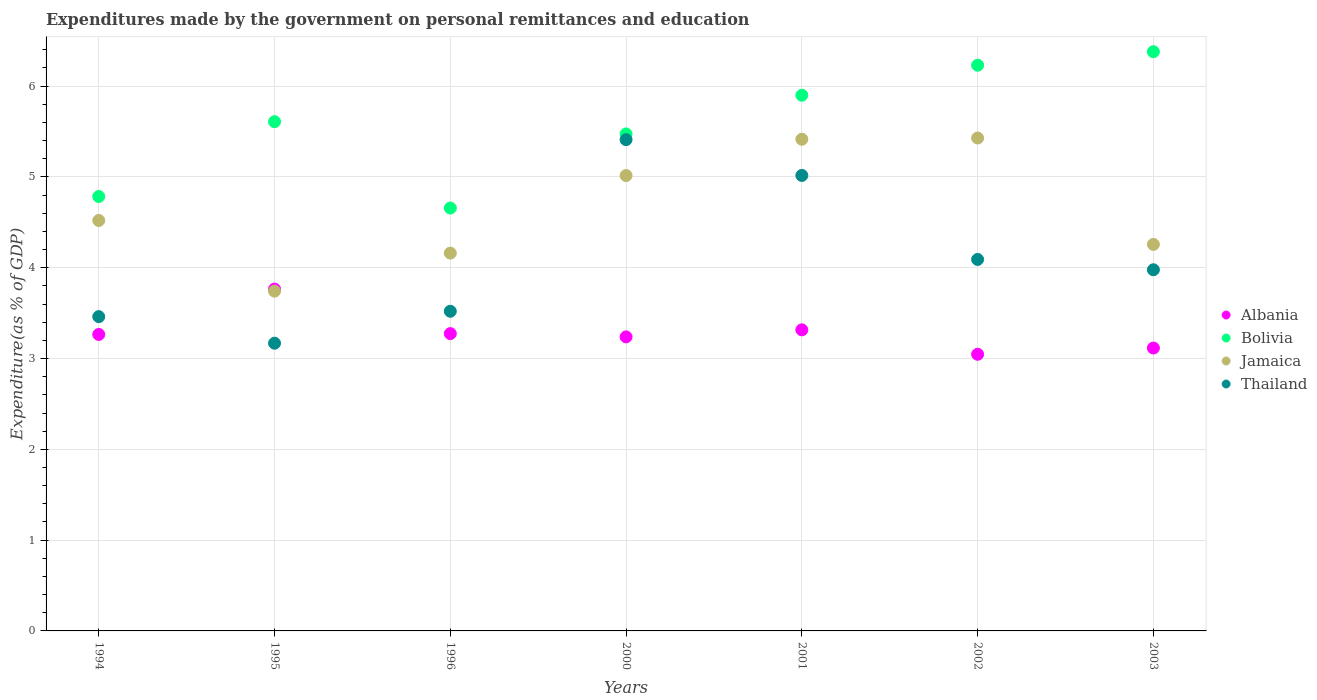What is the expenditures made by the government on personal remittances and education in Thailand in 2000?
Your response must be concise. 5.41. Across all years, what is the maximum expenditures made by the government on personal remittances and education in Bolivia?
Give a very brief answer. 6.38. Across all years, what is the minimum expenditures made by the government on personal remittances and education in Albania?
Your response must be concise. 3.05. In which year was the expenditures made by the government on personal remittances and education in Thailand maximum?
Provide a succinct answer. 2000. In which year was the expenditures made by the government on personal remittances and education in Bolivia minimum?
Your answer should be very brief. 1996. What is the total expenditures made by the government on personal remittances and education in Albania in the graph?
Keep it short and to the point. 23.02. What is the difference between the expenditures made by the government on personal remittances and education in Jamaica in 1996 and that in 2000?
Provide a succinct answer. -0.85. What is the difference between the expenditures made by the government on personal remittances and education in Bolivia in 2002 and the expenditures made by the government on personal remittances and education in Thailand in 2000?
Keep it short and to the point. 0.82. What is the average expenditures made by the government on personal remittances and education in Albania per year?
Make the answer very short. 3.29. In the year 2003, what is the difference between the expenditures made by the government on personal remittances and education in Jamaica and expenditures made by the government on personal remittances and education in Bolivia?
Provide a succinct answer. -2.12. What is the ratio of the expenditures made by the government on personal remittances and education in Bolivia in 1996 to that in 2003?
Your answer should be compact. 0.73. Is the expenditures made by the government on personal remittances and education in Jamaica in 1994 less than that in 2003?
Keep it short and to the point. No. What is the difference between the highest and the second highest expenditures made by the government on personal remittances and education in Thailand?
Keep it short and to the point. 0.39. What is the difference between the highest and the lowest expenditures made by the government on personal remittances and education in Bolivia?
Your answer should be very brief. 1.72. Does the expenditures made by the government on personal remittances and education in Bolivia monotonically increase over the years?
Keep it short and to the point. No. Is the expenditures made by the government on personal remittances and education in Thailand strictly less than the expenditures made by the government on personal remittances and education in Albania over the years?
Ensure brevity in your answer.  No. What is the difference between two consecutive major ticks on the Y-axis?
Your answer should be very brief. 1. Are the values on the major ticks of Y-axis written in scientific E-notation?
Provide a succinct answer. No. Does the graph contain any zero values?
Your answer should be very brief. No. Does the graph contain grids?
Your answer should be very brief. Yes. Where does the legend appear in the graph?
Offer a very short reply. Center right. How many legend labels are there?
Offer a terse response. 4. How are the legend labels stacked?
Ensure brevity in your answer.  Vertical. What is the title of the graph?
Provide a short and direct response. Expenditures made by the government on personal remittances and education. What is the label or title of the X-axis?
Provide a short and direct response. Years. What is the label or title of the Y-axis?
Your answer should be compact. Expenditure(as % of GDP). What is the Expenditure(as % of GDP) in Albania in 1994?
Your answer should be very brief. 3.27. What is the Expenditure(as % of GDP) of Bolivia in 1994?
Provide a short and direct response. 4.78. What is the Expenditure(as % of GDP) of Jamaica in 1994?
Your response must be concise. 4.52. What is the Expenditure(as % of GDP) in Thailand in 1994?
Your answer should be compact. 3.46. What is the Expenditure(as % of GDP) in Albania in 1995?
Ensure brevity in your answer.  3.76. What is the Expenditure(as % of GDP) in Bolivia in 1995?
Offer a very short reply. 5.61. What is the Expenditure(as % of GDP) of Jamaica in 1995?
Give a very brief answer. 3.74. What is the Expenditure(as % of GDP) of Thailand in 1995?
Your answer should be compact. 3.17. What is the Expenditure(as % of GDP) of Albania in 1996?
Keep it short and to the point. 3.27. What is the Expenditure(as % of GDP) in Bolivia in 1996?
Your answer should be very brief. 4.66. What is the Expenditure(as % of GDP) in Jamaica in 1996?
Provide a succinct answer. 4.16. What is the Expenditure(as % of GDP) of Thailand in 1996?
Ensure brevity in your answer.  3.52. What is the Expenditure(as % of GDP) in Albania in 2000?
Keep it short and to the point. 3.24. What is the Expenditure(as % of GDP) of Bolivia in 2000?
Keep it short and to the point. 5.47. What is the Expenditure(as % of GDP) of Jamaica in 2000?
Offer a terse response. 5.02. What is the Expenditure(as % of GDP) in Thailand in 2000?
Provide a succinct answer. 5.41. What is the Expenditure(as % of GDP) in Albania in 2001?
Keep it short and to the point. 3.32. What is the Expenditure(as % of GDP) in Bolivia in 2001?
Make the answer very short. 5.9. What is the Expenditure(as % of GDP) in Jamaica in 2001?
Offer a very short reply. 5.41. What is the Expenditure(as % of GDP) of Thailand in 2001?
Keep it short and to the point. 5.02. What is the Expenditure(as % of GDP) of Albania in 2002?
Offer a terse response. 3.05. What is the Expenditure(as % of GDP) of Bolivia in 2002?
Offer a very short reply. 6.23. What is the Expenditure(as % of GDP) in Jamaica in 2002?
Offer a terse response. 5.43. What is the Expenditure(as % of GDP) of Thailand in 2002?
Make the answer very short. 4.09. What is the Expenditure(as % of GDP) of Albania in 2003?
Your response must be concise. 3.12. What is the Expenditure(as % of GDP) in Bolivia in 2003?
Provide a short and direct response. 6.38. What is the Expenditure(as % of GDP) of Jamaica in 2003?
Ensure brevity in your answer.  4.26. What is the Expenditure(as % of GDP) in Thailand in 2003?
Ensure brevity in your answer.  3.98. Across all years, what is the maximum Expenditure(as % of GDP) of Albania?
Provide a succinct answer. 3.76. Across all years, what is the maximum Expenditure(as % of GDP) of Bolivia?
Give a very brief answer. 6.38. Across all years, what is the maximum Expenditure(as % of GDP) of Jamaica?
Offer a very short reply. 5.43. Across all years, what is the maximum Expenditure(as % of GDP) of Thailand?
Provide a short and direct response. 5.41. Across all years, what is the minimum Expenditure(as % of GDP) in Albania?
Your answer should be compact. 3.05. Across all years, what is the minimum Expenditure(as % of GDP) in Bolivia?
Your response must be concise. 4.66. Across all years, what is the minimum Expenditure(as % of GDP) of Jamaica?
Ensure brevity in your answer.  3.74. Across all years, what is the minimum Expenditure(as % of GDP) of Thailand?
Offer a terse response. 3.17. What is the total Expenditure(as % of GDP) in Albania in the graph?
Offer a terse response. 23.02. What is the total Expenditure(as % of GDP) of Bolivia in the graph?
Provide a succinct answer. 39.03. What is the total Expenditure(as % of GDP) in Jamaica in the graph?
Give a very brief answer. 32.54. What is the total Expenditure(as % of GDP) in Thailand in the graph?
Ensure brevity in your answer.  28.65. What is the difference between the Expenditure(as % of GDP) in Albania in 1994 and that in 1995?
Provide a short and direct response. -0.5. What is the difference between the Expenditure(as % of GDP) in Bolivia in 1994 and that in 1995?
Offer a very short reply. -0.82. What is the difference between the Expenditure(as % of GDP) of Jamaica in 1994 and that in 1995?
Keep it short and to the point. 0.78. What is the difference between the Expenditure(as % of GDP) in Thailand in 1994 and that in 1995?
Give a very brief answer. 0.29. What is the difference between the Expenditure(as % of GDP) in Albania in 1994 and that in 1996?
Give a very brief answer. -0.01. What is the difference between the Expenditure(as % of GDP) in Bolivia in 1994 and that in 1996?
Provide a short and direct response. 0.13. What is the difference between the Expenditure(as % of GDP) in Jamaica in 1994 and that in 1996?
Provide a short and direct response. 0.36. What is the difference between the Expenditure(as % of GDP) in Thailand in 1994 and that in 1996?
Offer a very short reply. -0.06. What is the difference between the Expenditure(as % of GDP) of Albania in 1994 and that in 2000?
Keep it short and to the point. 0.03. What is the difference between the Expenditure(as % of GDP) in Bolivia in 1994 and that in 2000?
Offer a terse response. -0.69. What is the difference between the Expenditure(as % of GDP) of Jamaica in 1994 and that in 2000?
Your answer should be compact. -0.49. What is the difference between the Expenditure(as % of GDP) in Thailand in 1994 and that in 2000?
Your answer should be compact. -1.95. What is the difference between the Expenditure(as % of GDP) of Albania in 1994 and that in 2001?
Your answer should be very brief. -0.05. What is the difference between the Expenditure(as % of GDP) of Bolivia in 1994 and that in 2001?
Give a very brief answer. -1.12. What is the difference between the Expenditure(as % of GDP) of Jamaica in 1994 and that in 2001?
Provide a succinct answer. -0.89. What is the difference between the Expenditure(as % of GDP) in Thailand in 1994 and that in 2001?
Your answer should be very brief. -1.56. What is the difference between the Expenditure(as % of GDP) of Albania in 1994 and that in 2002?
Ensure brevity in your answer.  0.22. What is the difference between the Expenditure(as % of GDP) in Bolivia in 1994 and that in 2002?
Give a very brief answer. -1.45. What is the difference between the Expenditure(as % of GDP) of Jamaica in 1994 and that in 2002?
Make the answer very short. -0.91. What is the difference between the Expenditure(as % of GDP) of Thailand in 1994 and that in 2002?
Ensure brevity in your answer.  -0.63. What is the difference between the Expenditure(as % of GDP) in Albania in 1994 and that in 2003?
Your answer should be compact. 0.15. What is the difference between the Expenditure(as % of GDP) in Bolivia in 1994 and that in 2003?
Make the answer very short. -1.59. What is the difference between the Expenditure(as % of GDP) in Jamaica in 1994 and that in 2003?
Your answer should be compact. 0.26. What is the difference between the Expenditure(as % of GDP) of Thailand in 1994 and that in 2003?
Keep it short and to the point. -0.52. What is the difference between the Expenditure(as % of GDP) of Albania in 1995 and that in 1996?
Make the answer very short. 0.49. What is the difference between the Expenditure(as % of GDP) in Bolivia in 1995 and that in 1996?
Make the answer very short. 0.95. What is the difference between the Expenditure(as % of GDP) in Jamaica in 1995 and that in 1996?
Your answer should be very brief. -0.42. What is the difference between the Expenditure(as % of GDP) of Thailand in 1995 and that in 1996?
Offer a very short reply. -0.35. What is the difference between the Expenditure(as % of GDP) of Albania in 1995 and that in 2000?
Keep it short and to the point. 0.53. What is the difference between the Expenditure(as % of GDP) in Bolivia in 1995 and that in 2000?
Make the answer very short. 0.13. What is the difference between the Expenditure(as % of GDP) in Jamaica in 1995 and that in 2000?
Keep it short and to the point. -1.27. What is the difference between the Expenditure(as % of GDP) of Thailand in 1995 and that in 2000?
Keep it short and to the point. -2.24. What is the difference between the Expenditure(as % of GDP) of Albania in 1995 and that in 2001?
Make the answer very short. 0.45. What is the difference between the Expenditure(as % of GDP) in Bolivia in 1995 and that in 2001?
Ensure brevity in your answer.  -0.29. What is the difference between the Expenditure(as % of GDP) of Jamaica in 1995 and that in 2001?
Provide a short and direct response. -1.67. What is the difference between the Expenditure(as % of GDP) in Thailand in 1995 and that in 2001?
Provide a short and direct response. -1.85. What is the difference between the Expenditure(as % of GDP) in Albania in 1995 and that in 2002?
Keep it short and to the point. 0.72. What is the difference between the Expenditure(as % of GDP) in Bolivia in 1995 and that in 2002?
Keep it short and to the point. -0.62. What is the difference between the Expenditure(as % of GDP) in Jamaica in 1995 and that in 2002?
Your answer should be compact. -1.69. What is the difference between the Expenditure(as % of GDP) in Thailand in 1995 and that in 2002?
Keep it short and to the point. -0.92. What is the difference between the Expenditure(as % of GDP) of Albania in 1995 and that in 2003?
Your response must be concise. 0.65. What is the difference between the Expenditure(as % of GDP) in Bolivia in 1995 and that in 2003?
Give a very brief answer. -0.77. What is the difference between the Expenditure(as % of GDP) of Jamaica in 1995 and that in 2003?
Keep it short and to the point. -0.51. What is the difference between the Expenditure(as % of GDP) in Thailand in 1995 and that in 2003?
Your answer should be very brief. -0.81. What is the difference between the Expenditure(as % of GDP) of Albania in 1996 and that in 2000?
Make the answer very short. 0.04. What is the difference between the Expenditure(as % of GDP) of Bolivia in 1996 and that in 2000?
Make the answer very short. -0.82. What is the difference between the Expenditure(as % of GDP) in Jamaica in 1996 and that in 2000?
Keep it short and to the point. -0.85. What is the difference between the Expenditure(as % of GDP) of Thailand in 1996 and that in 2000?
Give a very brief answer. -1.89. What is the difference between the Expenditure(as % of GDP) in Albania in 1996 and that in 2001?
Keep it short and to the point. -0.04. What is the difference between the Expenditure(as % of GDP) in Bolivia in 1996 and that in 2001?
Provide a short and direct response. -1.24. What is the difference between the Expenditure(as % of GDP) in Jamaica in 1996 and that in 2001?
Keep it short and to the point. -1.25. What is the difference between the Expenditure(as % of GDP) in Thailand in 1996 and that in 2001?
Keep it short and to the point. -1.5. What is the difference between the Expenditure(as % of GDP) of Albania in 1996 and that in 2002?
Ensure brevity in your answer.  0.23. What is the difference between the Expenditure(as % of GDP) in Bolivia in 1996 and that in 2002?
Provide a short and direct response. -1.57. What is the difference between the Expenditure(as % of GDP) in Jamaica in 1996 and that in 2002?
Provide a short and direct response. -1.27. What is the difference between the Expenditure(as % of GDP) in Thailand in 1996 and that in 2002?
Keep it short and to the point. -0.57. What is the difference between the Expenditure(as % of GDP) of Albania in 1996 and that in 2003?
Your answer should be very brief. 0.16. What is the difference between the Expenditure(as % of GDP) of Bolivia in 1996 and that in 2003?
Offer a terse response. -1.72. What is the difference between the Expenditure(as % of GDP) of Jamaica in 1996 and that in 2003?
Your response must be concise. -0.1. What is the difference between the Expenditure(as % of GDP) of Thailand in 1996 and that in 2003?
Provide a succinct answer. -0.46. What is the difference between the Expenditure(as % of GDP) in Albania in 2000 and that in 2001?
Ensure brevity in your answer.  -0.08. What is the difference between the Expenditure(as % of GDP) of Bolivia in 2000 and that in 2001?
Your answer should be very brief. -0.43. What is the difference between the Expenditure(as % of GDP) in Jamaica in 2000 and that in 2001?
Provide a succinct answer. -0.4. What is the difference between the Expenditure(as % of GDP) in Thailand in 2000 and that in 2001?
Provide a succinct answer. 0.39. What is the difference between the Expenditure(as % of GDP) in Albania in 2000 and that in 2002?
Give a very brief answer. 0.19. What is the difference between the Expenditure(as % of GDP) of Bolivia in 2000 and that in 2002?
Offer a very short reply. -0.76. What is the difference between the Expenditure(as % of GDP) in Jamaica in 2000 and that in 2002?
Offer a terse response. -0.41. What is the difference between the Expenditure(as % of GDP) in Thailand in 2000 and that in 2002?
Provide a succinct answer. 1.32. What is the difference between the Expenditure(as % of GDP) in Albania in 2000 and that in 2003?
Provide a succinct answer. 0.12. What is the difference between the Expenditure(as % of GDP) in Bolivia in 2000 and that in 2003?
Make the answer very short. -0.91. What is the difference between the Expenditure(as % of GDP) of Jamaica in 2000 and that in 2003?
Ensure brevity in your answer.  0.76. What is the difference between the Expenditure(as % of GDP) of Thailand in 2000 and that in 2003?
Offer a terse response. 1.43. What is the difference between the Expenditure(as % of GDP) of Albania in 2001 and that in 2002?
Provide a succinct answer. 0.27. What is the difference between the Expenditure(as % of GDP) in Bolivia in 2001 and that in 2002?
Your response must be concise. -0.33. What is the difference between the Expenditure(as % of GDP) of Jamaica in 2001 and that in 2002?
Your answer should be compact. -0.01. What is the difference between the Expenditure(as % of GDP) in Thailand in 2001 and that in 2002?
Your answer should be compact. 0.93. What is the difference between the Expenditure(as % of GDP) in Albania in 2001 and that in 2003?
Make the answer very short. 0.2. What is the difference between the Expenditure(as % of GDP) in Bolivia in 2001 and that in 2003?
Ensure brevity in your answer.  -0.48. What is the difference between the Expenditure(as % of GDP) of Jamaica in 2001 and that in 2003?
Offer a terse response. 1.16. What is the difference between the Expenditure(as % of GDP) of Thailand in 2001 and that in 2003?
Offer a very short reply. 1.04. What is the difference between the Expenditure(as % of GDP) in Albania in 2002 and that in 2003?
Offer a very short reply. -0.07. What is the difference between the Expenditure(as % of GDP) of Bolivia in 2002 and that in 2003?
Offer a terse response. -0.15. What is the difference between the Expenditure(as % of GDP) in Jamaica in 2002 and that in 2003?
Your answer should be compact. 1.17. What is the difference between the Expenditure(as % of GDP) in Thailand in 2002 and that in 2003?
Keep it short and to the point. 0.11. What is the difference between the Expenditure(as % of GDP) of Albania in 1994 and the Expenditure(as % of GDP) of Bolivia in 1995?
Your response must be concise. -2.34. What is the difference between the Expenditure(as % of GDP) of Albania in 1994 and the Expenditure(as % of GDP) of Jamaica in 1995?
Ensure brevity in your answer.  -0.48. What is the difference between the Expenditure(as % of GDP) in Albania in 1994 and the Expenditure(as % of GDP) in Thailand in 1995?
Give a very brief answer. 0.1. What is the difference between the Expenditure(as % of GDP) of Bolivia in 1994 and the Expenditure(as % of GDP) of Jamaica in 1995?
Your answer should be very brief. 1.04. What is the difference between the Expenditure(as % of GDP) in Bolivia in 1994 and the Expenditure(as % of GDP) in Thailand in 1995?
Provide a short and direct response. 1.62. What is the difference between the Expenditure(as % of GDP) of Jamaica in 1994 and the Expenditure(as % of GDP) of Thailand in 1995?
Give a very brief answer. 1.35. What is the difference between the Expenditure(as % of GDP) in Albania in 1994 and the Expenditure(as % of GDP) in Bolivia in 1996?
Make the answer very short. -1.39. What is the difference between the Expenditure(as % of GDP) of Albania in 1994 and the Expenditure(as % of GDP) of Jamaica in 1996?
Offer a terse response. -0.9. What is the difference between the Expenditure(as % of GDP) of Albania in 1994 and the Expenditure(as % of GDP) of Thailand in 1996?
Ensure brevity in your answer.  -0.26. What is the difference between the Expenditure(as % of GDP) of Bolivia in 1994 and the Expenditure(as % of GDP) of Jamaica in 1996?
Your answer should be compact. 0.62. What is the difference between the Expenditure(as % of GDP) in Bolivia in 1994 and the Expenditure(as % of GDP) in Thailand in 1996?
Offer a very short reply. 1.26. What is the difference between the Expenditure(as % of GDP) of Jamaica in 1994 and the Expenditure(as % of GDP) of Thailand in 1996?
Your answer should be very brief. 1. What is the difference between the Expenditure(as % of GDP) of Albania in 1994 and the Expenditure(as % of GDP) of Bolivia in 2000?
Provide a succinct answer. -2.21. What is the difference between the Expenditure(as % of GDP) in Albania in 1994 and the Expenditure(as % of GDP) in Jamaica in 2000?
Ensure brevity in your answer.  -1.75. What is the difference between the Expenditure(as % of GDP) of Albania in 1994 and the Expenditure(as % of GDP) of Thailand in 2000?
Ensure brevity in your answer.  -2.15. What is the difference between the Expenditure(as % of GDP) of Bolivia in 1994 and the Expenditure(as % of GDP) of Jamaica in 2000?
Make the answer very short. -0.23. What is the difference between the Expenditure(as % of GDP) of Bolivia in 1994 and the Expenditure(as % of GDP) of Thailand in 2000?
Provide a short and direct response. -0.63. What is the difference between the Expenditure(as % of GDP) in Jamaica in 1994 and the Expenditure(as % of GDP) in Thailand in 2000?
Provide a short and direct response. -0.89. What is the difference between the Expenditure(as % of GDP) in Albania in 1994 and the Expenditure(as % of GDP) in Bolivia in 2001?
Keep it short and to the point. -2.63. What is the difference between the Expenditure(as % of GDP) in Albania in 1994 and the Expenditure(as % of GDP) in Jamaica in 2001?
Keep it short and to the point. -2.15. What is the difference between the Expenditure(as % of GDP) of Albania in 1994 and the Expenditure(as % of GDP) of Thailand in 2001?
Keep it short and to the point. -1.75. What is the difference between the Expenditure(as % of GDP) of Bolivia in 1994 and the Expenditure(as % of GDP) of Jamaica in 2001?
Keep it short and to the point. -0.63. What is the difference between the Expenditure(as % of GDP) of Bolivia in 1994 and the Expenditure(as % of GDP) of Thailand in 2001?
Your response must be concise. -0.23. What is the difference between the Expenditure(as % of GDP) of Jamaica in 1994 and the Expenditure(as % of GDP) of Thailand in 2001?
Your response must be concise. -0.5. What is the difference between the Expenditure(as % of GDP) of Albania in 1994 and the Expenditure(as % of GDP) of Bolivia in 2002?
Give a very brief answer. -2.97. What is the difference between the Expenditure(as % of GDP) in Albania in 1994 and the Expenditure(as % of GDP) in Jamaica in 2002?
Ensure brevity in your answer.  -2.16. What is the difference between the Expenditure(as % of GDP) in Albania in 1994 and the Expenditure(as % of GDP) in Thailand in 2002?
Provide a succinct answer. -0.83. What is the difference between the Expenditure(as % of GDP) of Bolivia in 1994 and the Expenditure(as % of GDP) of Jamaica in 2002?
Your response must be concise. -0.64. What is the difference between the Expenditure(as % of GDP) in Bolivia in 1994 and the Expenditure(as % of GDP) in Thailand in 2002?
Your response must be concise. 0.69. What is the difference between the Expenditure(as % of GDP) of Jamaica in 1994 and the Expenditure(as % of GDP) of Thailand in 2002?
Your answer should be compact. 0.43. What is the difference between the Expenditure(as % of GDP) in Albania in 1994 and the Expenditure(as % of GDP) in Bolivia in 2003?
Ensure brevity in your answer.  -3.11. What is the difference between the Expenditure(as % of GDP) of Albania in 1994 and the Expenditure(as % of GDP) of Jamaica in 2003?
Give a very brief answer. -0.99. What is the difference between the Expenditure(as % of GDP) in Albania in 1994 and the Expenditure(as % of GDP) in Thailand in 2003?
Give a very brief answer. -0.71. What is the difference between the Expenditure(as % of GDP) in Bolivia in 1994 and the Expenditure(as % of GDP) in Jamaica in 2003?
Ensure brevity in your answer.  0.53. What is the difference between the Expenditure(as % of GDP) in Bolivia in 1994 and the Expenditure(as % of GDP) in Thailand in 2003?
Offer a terse response. 0.81. What is the difference between the Expenditure(as % of GDP) in Jamaica in 1994 and the Expenditure(as % of GDP) in Thailand in 2003?
Provide a succinct answer. 0.54. What is the difference between the Expenditure(as % of GDP) of Albania in 1995 and the Expenditure(as % of GDP) of Bolivia in 1996?
Offer a terse response. -0.89. What is the difference between the Expenditure(as % of GDP) in Albania in 1995 and the Expenditure(as % of GDP) in Jamaica in 1996?
Your answer should be compact. -0.4. What is the difference between the Expenditure(as % of GDP) of Albania in 1995 and the Expenditure(as % of GDP) of Thailand in 1996?
Provide a succinct answer. 0.24. What is the difference between the Expenditure(as % of GDP) in Bolivia in 1995 and the Expenditure(as % of GDP) in Jamaica in 1996?
Offer a terse response. 1.45. What is the difference between the Expenditure(as % of GDP) in Bolivia in 1995 and the Expenditure(as % of GDP) in Thailand in 1996?
Make the answer very short. 2.09. What is the difference between the Expenditure(as % of GDP) of Jamaica in 1995 and the Expenditure(as % of GDP) of Thailand in 1996?
Offer a terse response. 0.22. What is the difference between the Expenditure(as % of GDP) of Albania in 1995 and the Expenditure(as % of GDP) of Bolivia in 2000?
Ensure brevity in your answer.  -1.71. What is the difference between the Expenditure(as % of GDP) in Albania in 1995 and the Expenditure(as % of GDP) in Jamaica in 2000?
Provide a succinct answer. -1.25. What is the difference between the Expenditure(as % of GDP) of Albania in 1995 and the Expenditure(as % of GDP) of Thailand in 2000?
Provide a short and direct response. -1.65. What is the difference between the Expenditure(as % of GDP) in Bolivia in 1995 and the Expenditure(as % of GDP) in Jamaica in 2000?
Offer a very short reply. 0.59. What is the difference between the Expenditure(as % of GDP) in Bolivia in 1995 and the Expenditure(as % of GDP) in Thailand in 2000?
Offer a terse response. 0.2. What is the difference between the Expenditure(as % of GDP) of Jamaica in 1995 and the Expenditure(as % of GDP) of Thailand in 2000?
Provide a succinct answer. -1.67. What is the difference between the Expenditure(as % of GDP) in Albania in 1995 and the Expenditure(as % of GDP) in Bolivia in 2001?
Ensure brevity in your answer.  -2.13. What is the difference between the Expenditure(as % of GDP) of Albania in 1995 and the Expenditure(as % of GDP) of Jamaica in 2001?
Provide a short and direct response. -1.65. What is the difference between the Expenditure(as % of GDP) of Albania in 1995 and the Expenditure(as % of GDP) of Thailand in 2001?
Your answer should be very brief. -1.25. What is the difference between the Expenditure(as % of GDP) of Bolivia in 1995 and the Expenditure(as % of GDP) of Jamaica in 2001?
Make the answer very short. 0.19. What is the difference between the Expenditure(as % of GDP) in Bolivia in 1995 and the Expenditure(as % of GDP) in Thailand in 2001?
Keep it short and to the point. 0.59. What is the difference between the Expenditure(as % of GDP) of Jamaica in 1995 and the Expenditure(as % of GDP) of Thailand in 2001?
Provide a short and direct response. -1.27. What is the difference between the Expenditure(as % of GDP) in Albania in 1995 and the Expenditure(as % of GDP) in Bolivia in 2002?
Provide a succinct answer. -2.47. What is the difference between the Expenditure(as % of GDP) in Albania in 1995 and the Expenditure(as % of GDP) in Jamaica in 2002?
Keep it short and to the point. -1.66. What is the difference between the Expenditure(as % of GDP) in Albania in 1995 and the Expenditure(as % of GDP) in Thailand in 2002?
Offer a very short reply. -0.33. What is the difference between the Expenditure(as % of GDP) of Bolivia in 1995 and the Expenditure(as % of GDP) of Jamaica in 2002?
Offer a very short reply. 0.18. What is the difference between the Expenditure(as % of GDP) of Bolivia in 1995 and the Expenditure(as % of GDP) of Thailand in 2002?
Your response must be concise. 1.52. What is the difference between the Expenditure(as % of GDP) of Jamaica in 1995 and the Expenditure(as % of GDP) of Thailand in 2002?
Offer a very short reply. -0.35. What is the difference between the Expenditure(as % of GDP) in Albania in 1995 and the Expenditure(as % of GDP) in Bolivia in 2003?
Keep it short and to the point. -2.61. What is the difference between the Expenditure(as % of GDP) in Albania in 1995 and the Expenditure(as % of GDP) in Jamaica in 2003?
Offer a terse response. -0.49. What is the difference between the Expenditure(as % of GDP) in Albania in 1995 and the Expenditure(as % of GDP) in Thailand in 2003?
Make the answer very short. -0.21. What is the difference between the Expenditure(as % of GDP) in Bolivia in 1995 and the Expenditure(as % of GDP) in Jamaica in 2003?
Give a very brief answer. 1.35. What is the difference between the Expenditure(as % of GDP) of Bolivia in 1995 and the Expenditure(as % of GDP) of Thailand in 2003?
Your answer should be compact. 1.63. What is the difference between the Expenditure(as % of GDP) in Jamaica in 1995 and the Expenditure(as % of GDP) in Thailand in 2003?
Provide a succinct answer. -0.24. What is the difference between the Expenditure(as % of GDP) in Albania in 1996 and the Expenditure(as % of GDP) in Bolivia in 2000?
Your answer should be compact. -2.2. What is the difference between the Expenditure(as % of GDP) in Albania in 1996 and the Expenditure(as % of GDP) in Jamaica in 2000?
Provide a short and direct response. -1.74. What is the difference between the Expenditure(as % of GDP) in Albania in 1996 and the Expenditure(as % of GDP) in Thailand in 2000?
Offer a very short reply. -2.14. What is the difference between the Expenditure(as % of GDP) of Bolivia in 1996 and the Expenditure(as % of GDP) of Jamaica in 2000?
Your answer should be compact. -0.36. What is the difference between the Expenditure(as % of GDP) in Bolivia in 1996 and the Expenditure(as % of GDP) in Thailand in 2000?
Your answer should be compact. -0.75. What is the difference between the Expenditure(as % of GDP) of Jamaica in 1996 and the Expenditure(as % of GDP) of Thailand in 2000?
Your response must be concise. -1.25. What is the difference between the Expenditure(as % of GDP) in Albania in 1996 and the Expenditure(as % of GDP) in Bolivia in 2001?
Your response must be concise. -2.63. What is the difference between the Expenditure(as % of GDP) in Albania in 1996 and the Expenditure(as % of GDP) in Jamaica in 2001?
Provide a succinct answer. -2.14. What is the difference between the Expenditure(as % of GDP) in Albania in 1996 and the Expenditure(as % of GDP) in Thailand in 2001?
Provide a short and direct response. -1.74. What is the difference between the Expenditure(as % of GDP) of Bolivia in 1996 and the Expenditure(as % of GDP) of Jamaica in 2001?
Offer a very short reply. -0.76. What is the difference between the Expenditure(as % of GDP) in Bolivia in 1996 and the Expenditure(as % of GDP) in Thailand in 2001?
Provide a short and direct response. -0.36. What is the difference between the Expenditure(as % of GDP) in Jamaica in 1996 and the Expenditure(as % of GDP) in Thailand in 2001?
Your answer should be compact. -0.86. What is the difference between the Expenditure(as % of GDP) of Albania in 1996 and the Expenditure(as % of GDP) of Bolivia in 2002?
Give a very brief answer. -2.96. What is the difference between the Expenditure(as % of GDP) of Albania in 1996 and the Expenditure(as % of GDP) of Jamaica in 2002?
Offer a very short reply. -2.15. What is the difference between the Expenditure(as % of GDP) of Albania in 1996 and the Expenditure(as % of GDP) of Thailand in 2002?
Ensure brevity in your answer.  -0.82. What is the difference between the Expenditure(as % of GDP) of Bolivia in 1996 and the Expenditure(as % of GDP) of Jamaica in 2002?
Make the answer very short. -0.77. What is the difference between the Expenditure(as % of GDP) in Bolivia in 1996 and the Expenditure(as % of GDP) in Thailand in 2002?
Your answer should be compact. 0.57. What is the difference between the Expenditure(as % of GDP) of Jamaica in 1996 and the Expenditure(as % of GDP) of Thailand in 2002?
Your response must be concise. 0.07. What is the difference between the Expenditure(as % of GDP) of Albania in 1996 and the Expenditure(as % of GDP) of Bolivia in 2003?
Your response must be concise. -3.1. What is the difference between the Expenditure(as % of GDP) in Albania in 1996 and the Expenditure(as % of GDP) in Jamaica in 2003?
Keep it short and to the point. -0.98. What is the difference between the Expenditure(as % of GDP) in Albania in 1996 and the Expenditure(as % of GDP) in Thailand in 2003?
Keep it short and to the point. -0.7. What is the difference between the Expenditure(as % of GDP) of Bolivia in 1996 and the Expenditure(as % of GDP) of Jamaica in 2003?
Keep it short and to the point. 0.4. What is the difference between the Expenditure(as % of GDP) of Bolivia in 1996 and the Expenditure(as % of GDP) of Thailand in 2003?
Keep it short and to the point. 0.68. What is the difference between the Expenditure(as % of GDP) of Jamaica in 1996 and the Expenditure(as % of GDP) of Thailand in 2003?
Provide a short and direct response. 0.18. What is the difference between the Expenditure(as % of GDP) of Albania in 2000 and the Expenditure(as % of GDP) of Bolivia in 2001?
Give a very brief answer. -2.66. What is the difference between the Expenditure(as % of GDP) in Albania in 2000 and the Expenditure(as % of GDP) in Jamaica in 2001?
Your response must be concise. -2.18. What is the difference between the Expenditure(as % of GDP) in Albania in 2000 and the Expenditure(as % of GDP) in Thailand in 2001?
Provide a short and direct response. -1.78. What is the difference between the Expenditure(as % of GDP) of Bolivia in 2000 and the Expenditure(as % of GDP) of Jamaica in 2001?
Provide a short and direct response. 0.06. What is the difference between the Expenditure(as % of GDP) of Bolivia in 2000 and the Expenditure(as % of GDP) of Thailand in 2001?
Make the answer very short. 0.46. What is the difference between the Expenditure(as % of GDP) of Jamaica in 2000 and the Expenditure(as % of GDP) of Thailand in 2001?
Give a very brief answer. -0. What is the difference between the Expenditure(as % of GDP) of Albania in 2000 and the Expenditure(as % of GDP) of Bolivia in 2002?
Your answer should be compact. -2.99. What is the difference between the Expenditure(as % of GDP) in Albania in 2000 and the Expenditure(as % of GDP) in Jamaica in 2002?
Your answer should be very brief. -2.19. What is the difference between the Expenditure(as % of GDP) of Albania in 2000 and the Expenditure(as % of GDP) of Thailand in 2002?
Ensure brevity in your answer.  -0.85. What is the difference between the Expenditure(as % of GDP) of Bolivia in 2000 and the Expenditure(as % of GDP) of Jamaica in 2002?
Make the answer very short. 0.04. What is the difference between the Expenditure(as % of GDP) of Bolivia in 2000 and the Expenditure(as % of GDP) of Thailand in 2002?
Offer a very short reply. 1.38. What is the difference between the Expenditure(as % of GDP) in Jamaica in 2000 and the Expenditure(as % of GDP) in Thailand in 2002?
Your answer should be compact. 0.92. What is the difference between the Expenditure(as % of GDP) of Albania in 2000 and the Expenditure(as % of GDP) of Bolivia in 2003?
Keep it short and to the point. -3.14. What is the difference between the Expenditure(as % of GDP) of Albania in 2000 and the Expenditure(as % of GDP) of Jamaica in 2003?
Make the answer very short. -1.02. What is the difference between the Expenditure(as % of GDP) of Albania in 2000 and the Expenditure(as % of GDP) of Thailand in 2003?
Give a very brief answer. -0.74. What is the difference between the Expenditure(as % of GDP) in Bolivia in 2000 and the Expenditure(as % of GDP) in Jamaica in 2003?
Provide a succinct answer. 1.22. What is the difference between the Expenditure(as % of GDP) in Bolivia in 2000 and the Expenditure(as % of GDP) in Thailand in 2003?
Make the answer very short. 1.5. What is the difference between the Expenditure(as % of GDP) of Jamaica in 2000 and the Expenditure(as % of GDP) of Thailand in 2003?
Ensure brevity in your answer.  1.04. What is the difference between the Expenditure(as % of GDP) in Albania in 2001 and the Expenditure(as % of GDP) in Bolivia in 2002?
Make the answer very short. -2.91. What is the difference between the Expenditure(as % of GDP) of Albania in 2001 and the Expenditure(as % of GDP) of Jamaica in 2002?
Keep it short and to the point. -2.11. What is the difference between the Expenditure(as % of GDP) of Albania in 2001 and the Expenditure(as % of GDP) of Thailand in 2002?
Your answer should be very brief. -0.78. What is the difference between the Expenditure(as % of GDP) in Bolivia in 2001 and the Expenditure(as % of GDP) in Jamaica in 2002?
Provide a short and direct response. 0.47. What is the difference between the Expenditure(as % of GDP) of Bolivia in 2001 and the Expenditure(as % of GDP) of Thailand in 2002?
Provide a short and direct response. 1.81. What is the difference between the Expenditure(as % of GDP) of Jamaica in 2001 and the Expenditure(as % of GDP) of Thailand in 2002?
Offer a very short reply. 1.32. What is the difference between the Expenditure(as % of GDP) of Albania in 2001 and the Expenditure(as % of GDP) of Bolivia in 2003?
Offer a terse response. -3.06. What is the difference between the Expenditure(as % of GDP) of Albania in 2001 and the Expenditure(as % of GDP) of Jamaica in 2003?
Offer a terse response. -0.94. What is the difference between the Expenditure(as % of GDP) in Albania in 2001 and the Expenditure(as % of GDP) in Thailand in 2003?
Keep it short and to the point. -0.66. What is the difference between the Expenditure(as % of GDP) in Bolivia in 2001 and the Expenditure(as % of GDP) in Jamaica in 2003?
Make the answer very short. 1.64. What is the difference between the Expenditure(as % of GDP) of Bolivia in 2001 and the Expenditure(as % of GDP) of Thailand in 2003?
Your answer should be compact. 1.92. What is the difference between the Expenditure(as % of GDP) in Jamaica in 2001 and the Expenditure(as % of GDP) in Thailand in 2003?
Make the answer very short. 1.44. What is the difference between the Expenditure(as % of GDP) of Albania in 2002 and the Expenditure(as % of GDP) of Bolivia in 2003?
Provide a succinct answer. -3.33. What is the difference between the Expenditure(as % of GDP) in Albania in 2002 and the Expenditure(as % of GDP) in Jamaica in 2003?
Provide a succinct answer. -1.21. What is the difference between the Expenditure(as % of GDP) in Albania in 2002 and the Expenditure(as % of GDP) in Thailand in 2003?
Your answer should be compact. -0.93. What is the difference between the Expenditure(as % of GDP) of Bolivia in 2002 and the Expenditure(as % of GDP) of Jamaica in 2003?
Offer a very short reply. 1.97. What is the difference between the Expenditure(as % of GDP) of Bolivia in 2002 and the Expenditure(as % of GDP) of Thailand in 2003?
Your response must be concise. 2.25. What is the difference between the Expenditure(as % of GDP) of Jamaica in 2002 and the Expenditure(as % of GDP) of Thailand in 2003?
Give a very brief answer. 1.45. What is the average Expenditure(as % of GDP) in Albania per year?
Ensure brevity in your answer.  3.29. What is the average Expenditure(as % of GDP) in Bolivia per year?
Ensure brevity in your answer.  5.58. What is the average Expenditure(as % of GDP) of Jamaica per year?
Give a very brief answer. 4.65. What is the average Expenditure(as % of GDP) of Thailand per year?
Provide a succinct answer. 4.09. In the year 1994, what is the difference between the Expenditure(as % of GDP) of Albania and Expenditure(as % of GDP) of Bolivia?
Ensure brevity in your answer.  -1.52. In the year 1994, what is the difference between the Expenditure(as % of GDP) in Albania and Expenditure(as % of GDP) in Jamaica?
Provide a short and direct response. -1.26. In the year 1994, what is the difference between the Expenditure(as % of GDP) of Albania and Expenditure(as % of GDP) of Thailand?
Keep it short and to the point. -0.2. In the year 1994, what is the difference between the Expenditure(as % of GDP) in Bolivia and Expenditure(as % of GDP) in Jamaica?
Offer a terse response. 0.26. In the year 1994, what is the difference between the Expenditure(as % of GDP) in Bolivia and Expenditure(as % of GDP) in Thailand?
Offer a terse response. 1.32. In the year 1994, what is the difference between the Expenditure(as % of GDP) in Jamaica and Expenditure(as % of GDP) in Thailand?
Ensure brevity in your answer.  1.06. In the year 1995, what is the difference between the Expenditure(as % of GDP) of Albania and Expenditure(as % of GDP) of Bolivia?
Make the answer very short. -1.84. In the year 1995, what is the difference between the Expenditure(as % of GDP) of Albania and Expenditure(as % of GDP) of Jamaica?
Provide a short and direct response. 0.02. In the year 1995, what is the difference between the Expenditure(as % of GDP) of Albania and Expenditure(as % of GDP) of Thailand?
Your answer should be compact. 0.6. In the year 1995, what is the difference between the Expenditure(as % of GDP) of Bolivia and Expenditure(as % of GDP) of Jamaica?
Offer a very short reply. 1.87. In the year 1995, what is the difference between the Expenditure(as % of GDP) of Bolivia and Expenditure(as % of GDP) of Thailand?
Provide a succinct answer. 2.44. In the year 1995, what is the difference between the Expenditure(as % of GDP) of Jamaica and Expenditure(as % of GDP) of Thailand?
Provide a short and direct response. 0.57. In the year 1996, what is the difference between the Expenditure(as % of GDP) in Albania and Expenditure(as % of GDP) in Bolivia?
Your answer should be very brief. -1.38. In the year 1996, what is the difference between the Expenditure(as % of GDP) in Albania and Expenditure(as % of GDP) in Jamaica?
Keep it short and to the point. -0.89. In the year 1996, what is the difference between the Expenditure(as % of GDP) of Albania and Expenditure(as % of GDP) of Thailand?
Ensure brevity in your answer.  -0.25. In the year 1996, what is the difference between the Expenditure(as % of GDP) of Bolivia and Expenditure(as % of GDP) of Jamaica?
Give a very brief answer. 0.5. In the year 1996, what is the difference between the Expenditure(as % of GDP) of Bolivia and Expenditure(as % of GDP) of Thailand?
Ensure brevity in your answer.  1.14. In the year 1996, what is the difference between the Expenditure(as % of GDP) in Jamaica and Expenditure(as % of GDP) in Thailand?
Your answer should be very brief. 0.64. In the year 2000, what is the difference between the Expenditure(as % of GDP) of Albania and Expenditure(as % of GDP) of Bolivia?
Provide a succinct answer. -2.24. In the year 2000, what is the difference between the Expenditure(as % of GDP) in Albania and Expenditure(as % of GDP) in Jamaica?
Provide a short and direct response. -1.78. In the year 2000, what is the difference between the Expenditure(as % of GDP) of Albania and Expenditure(as % of GDP) of Thailand?
Provide a succinct answer. -2.17. In the year 2000, what is the difference between the Expenditure(as % of GDP) in Bolivia and Expenditure(as % of GDP) in Jamaica?
Offer a terse response. 0.46. In the year 2000, what is the difference between the Expenditure(as % of GDP) in Bolivia and Expenditure(as % of GDP) in Thailand?
Ensure brevity in your answer.  0.06. In the year 2000, what is the difference between the Expenditure(as % of GDP) in Jamaica and Expenditure(as % of GDP) in Thailand?
Ensure brevity in your answer.  -0.4. In the year 2001, what is the difference between the Expenditure(as % of GDP) in Albania and Expenditure(as % of GDP) in Bolivia?
Provide a succinct answer. -2.58. In the year 2001, what is the difference between the Expenditure(as % of GDP) of Albania and Expenditure(as % of GDP) of Jamaica?
Make the answer very short. -2.1. In the year 2001, what is the difference between the Expenditure(as % of GDP) in Albania and Expenditure(as % of GDP) in Thailand?
Your answer should be compact. -1.7. In the year 2001, what is the difference between the Expenditure(as % of GDP) in Bolivia and Expenditure(as % of GDP) in Jamaica?
Offer a very short reply. 0.48. In the year 2001, what is the difference between the Expenditure(as % of GDP) of Bolivia and Expenditure(as % of GDP) of Thailand?
Offer a terse response. 0.88. In the year 2001, what is the difference between the Expenditure(as % of GDP) in Jamaica and Expenditure(as % of GDP) in Thailand?
Ensure brevity in your answer.  0.4. In the year 2002, what is the difference between the Expenditure(as % of GDP) in Albania and Expenditure(as % of GDP) in Bolivia?
Give a very brief answer. -3.18. In the year 2002, what is the difference between the Expenditure(as % of GDP) in Albania and Expenditure(as % of GDP) in Jamaica?
Your answer should be very brief. -2.38. In the year 2002, what is the difference between the Expenditure(as % of GDP) of Albania and Expenditure(as % of GDP) of Thailand?
Your answer should be very brief. -1.04. In the year 2002, what is the difference between the Expenditure(as % of GDP) of Bolivia and Expenditure(as % of GDP) of Jamaica?
Keep it short and to the point. 0.8. In the year 2002, what is the difference between the Expenditure(as % of GDP) in Bolivia and Expenditure(as % of GDP) in Thailand?
Provide a short and direct response. 2.14. In the year 2002, what is the difference between the Expenditure(as % of GDP) of Jamaica and Expenditure(as % of GDP) of Thailand?
Provide a succinct answer. 1.34. In the year 2003, what is the difference between the Expenditure(as % of GDP) of Albania and Expenditure(as % of GDP) of Bolivia?
Offer a terse response. -3.26. In the year 2003, what is the difference between the Expenditure(as % of GDP) in Albania and Expenditure(as % of GDP) in Jamaica?
Your answer should be very brief. -1.14. In the year 2003, what is the difference between the Expenditure(as % of GDP) of Albania and Expenditure(as % of GDP) of Thailand?
Provide a succinct answer. -0.86. In the year 2003, what is the difference between the Expenditure(as % of GDP) of Bolivia and Expenditure(as % of GDP) of Jamaica?
Your answer should be very brief. 2.12. In the year 2003, what is the difference between the Expenditure(as % of GDP) in Bolivia and Expenditure(as % of GDP) in Thailand?
Provide a short and direct response. 2.4. In the year 2003, what is the difference between the Expenditure(as % of GDP) of Jamaica and Expenditure(as % of GDP) of Thailand?
Your response must be concise. 0.28. What is the ratio of the Expenditure(as % of GDP) in Albania in 1994 to that in 1995?
Offer a terse response. 0.87. What is the ratio of the Expenditure(as % of GDP) in Bolivia in 1994 to that in 1995?
Your answer should be compact. 0.85. What is the ratio of the Expenditure(as % of GDP) in Jamaica in 1994 to that in 1995?
Make the answer very short. 1.21. What is the ratio of the Expenditure(as % of GDP) in Thailand in 1994 to that in 1995?
Keep it short and to the point. 1.09. What is the ratio of the Expenditure(as % of GDP) in Bolivia in 1994 to that in 1996?
Your answer should be compact. 1.03. What is the ratio of the Expenditure(as % of GDP) of Jamaica in 1994 to that in 1996?
Provide a succinct answer. 1.09. What is the ratio of the Expenditure(as % of GDP) in Thailand in 1994 to that in 1996?
Ensure brevity in your answer.  0.98. What is the ratio of the Expenditure(as % of GDP) in Albania in 1994 to that in 2000?
Give a very brief answer. 1.01. What is the ratio of the Expenditure(as % of GDP) in Bolivia in 1994 to that in 2000?
Offer a terse response. 0.87. What is the ratio of the Expenditure(as % of GDP) in Jamaica in 1994 to that in 2000?
Offer a terse response. 0.9. What is the ratio of the Expenditure(as % of GDP) of Thailand in 1994 to that in 2000?
Make the answer very short. 0.64. What is the ratio of the Expenditure(as % of GDP) of Albania in 1994 to that in 2001?
Your answer should be compact. 0.98. What is the ratio of the Expenditure(as % of GDP) in Bolivia in 1994 to that in 2001?
Offer a very short reply. 0.81. What is the ratio of the Expenditure(as % of GDP) of Jamaica in 1994 to that in 2001?
Your answer should be compact. 0.83. What is the ratio of the Expenditure(as % of GDP) of Thailand in 1994 to that in 2001?
Give a very brief answer. 0.69. What is the ratio of the Expenditure(as % of GDP) of Albania in 1994 to that in 2002?
Your answer should be compact. 1.07. What is the ratio of the Expenditure(as % of GDP) in Bolivia in 1994 to that in 2002?
Offer a very short reply. 0.77. What is the ratio of the Expenditure(as % of GDP) in Jamaica in 1994 to that in 2002?
Ensure brevity in your answer.  0.83. What is the ratio of the Expenditure(as % of GDP) in Thailand in 1994 to that in 2002?
Offer a terse response. 0.85. What is the ratio of the Expenditure(as % of GDP) of Albania in 1994 to that in 2003?
Give a very brief answer. 1.05. What is the ratio of the Expenditure(as % of GDP) in Jamaica in 1994 to that in 2003?
Provide a succinct answer. 1.06. What is the ratio of the Expenditure(as % of GDP) in Thailand in 1994 to that in 2003?
Provide a succinct answer. 0.87. What is the ratio of the Expenditure(as % of GDP) of Albania in 1995 to that in 1996?
Give a very brief answer. 1.15. What is the ratio of the Expenditure(as % of GDP) of Bolivia in 1995 to that in 1996?
Offer a very short reply. 1.2. What is the ratio of the Expenditure(as % of GDP) in Jamaica in 1995 to that in 1996?
Offer a terse response. 0.9. What is the ratio of the Expenditure(as % of GDP) of Thailand in 1995 to that in 1996?
Offer a very short reply. 0.9. What is the ratio of the Expenditure(as % of GDP) of Albania in 1995 to that in 2000?
Provide a short and direct response. 1.16. What is the ratio of the Expenditure(as % of GDP) of Bolivia in 1995 to that in 2000?
Offer a terse response. 1.02. What is the ratio of the Expenditure(as % of GDP) in Jamaica in 1995 to that in 2000?
Offer a terse response. 0.75. What is the ratio of the Expenditure(as % of GDP) of Thailand in 1995 to that in 2000?
Keep it short and to the point. 0.59. What is the ratio of the Expenditure(as % of GDP) in Albania in 1995 to that in 2001?
Offer a very short reply. 1.14. What is the ratio of the Expenditure(as % of GDP) in Bolivia in 1995 to that in 2001?
Your response must be concise. 0.95. What is the ratio of the Expenditure(as % of GDP) in Jamaica in 1995 to that in 2001?
Offer a terse response. 0.69. What is the ratio of the Expenditure(as % of GDP) of Thailand in 1995 to that in 2001?
Offer a very short reply. 0.63. What is the ratio of the Expenditure(as % of GDP) in Albania in 1995 to that in 2002?
Keep it short and to the point. 1.24. What is the ratio of the Expenditure(as % of GDP) of Bolivia in 1995 to that in 2002?
Offer a terse response. 0.9. What is the ratio of the Expenditure(as % of GDP) of Jamaica in 1995 to that in 2002?
Ensure brevity in your answer.  0.69. What is the ratio of the Expenditure(as % of GDP) of Thailand in 1995 to that in 2002?
Provide a succinct answer. 0.77. What is the ratio of the Expenditure(as % of GDP) in Albania in 1995 to that in 2003?
Give a very brief answer. 1.21. What is the ratio of the Expenditure(as % of GDP) in Bolivia in 1995 to that in 2003?
Make the answer very short. 0.88. What is the ratio of the Expenditure(as % of GDP) of Jamaica in 1995 to that in 2003?
Give a very brief answer. 0.88. What is the ratio of the Expenditure(as % of GDP) in Thailand in 1995 to that in 2003?
Provide a succinct answer. 0.8. What is the ratio of the Expenditure(as % of GDP) of Albania in 1996 to that in 2000?
Your answer should be very brief. 1.01. What is the ratio of the Expenditure(as % of GDP) of Bolivia in 1996 to that in 2000?
Give a very brief answer. 0.85. What is the ratio of the Expenditure(as % of GDP) in Jamaica in 1996 to that in 2000?
Your response must be concise. 0.83. What is the ratio of the Expenditure(as % of GDP) in Thailand in 1996 to that in 2000?
Provide a short and direct response. 0.65. What is the ratio of the Expenditure(as % of GDP) in Albania in 1996 to that in 2001?
Keep it short and to the point. 0.99. What is the ratio of the Expenditure(as % of GDP) of Bolivia in 1996 to that in 2001?
Your answer should be very brief. 0.79. What is the ratio of the Expenditure(as % of GDP) in Jamaica in 1996 to that in 2001?
Your answer should be compact. 0.77. What is the ratio of the Expenditure(as % of GDP) of Thailand in 1996 to that in 2001?
Ensure brevity in your answer.  0.7. What is the ratio of the Expenditure(as % of GDP) of Albania in 1996 to that in 2002?
Keep it short and to the point. 1.07. What is the ratio of the Expenditure(as % of GDP) in Bolivia in 1996 to that in 2002?
Make the answer very short. 0.75. What is the ratio of the Expenditure(as % of GDP) in Jamaica in 1996 to that in 2002?
Ensure brevity in your answer.  0.77. What is the ratio of the Expenditure(as % of GDP) of Thailand in 1996 to that in 2002?
Your response must be concise. 0.86. What is the ratio of the Expenditure(as % of GDP) in Albania in 1996 to that in 2003?
Keep it short and to the point. 1.05. What is the ratio of the Expenditure(as % of GDP) of Bolivia in 1996 to that in 2003?
Offer a terse response. 0.73. What is the ratio of the Expenditure(as % of GDP) in Jamaica in 1996 to that in 2003?
Your answer should be very brief. 0.98. What is the ratio of the Expenditure(as % of GDP) of Thailand in 1996 to that in 2003?
Offer a terse response. 0.89. What is the ratio of the Expenditure(as % of GDP) in Albania in 2000 to that in 2001?
Offer a terse response. 0.98. What is the ratio of the Expenditure(as % of GDP) of Bolivia in 2000 to that in 2001?
Provide a succinct answer. 0.93. What is the ratio of the Expenditure(as % of GDP) of Jamaica in 2000 to that in 2001?
Keep it short and to the point. 0.93. What is the ratio of the Expenditure(as % of GDP) in Thailand in 2000 to that in 2001?
Offer a terse response. 1.08. What is the ratio of the Expenditure(as % of GDP) in Albania in 2000 to that in 2002?
Make the answer very short. 1.06. What is the ratio of the Expenditure(as % of GDP) of Bolivia in 2000 to that in 2002?
Your answer should be very brief. 0.88. What is the ratio of the Expenditure(as % of GDP) of Jamaica in 2000 to that in 2002?
Keep it short and to the point. 0.92. What is the ratio of the Expenditure(as % of GDP) of Thailand in 2000 to that in 2002?
Your answer should be compact. 1.32. What is the ratio of the Expenditure(as % of GDP) of Albania in 2000 to that in 2003?
Your answer should be very brief. 1.04. What is the ratio of the Expenditure(as % of GDP) in Bolivia in 2000 to that in 2003?
Give a very brief answer. 0.86. What is the ratio of the Expenditure(as % of GDP) in Jamaica in 2000 to that in 2003?
Offer a terse response. 1.18. What is the ratio of the Expenditure(as % of GDP) in Thailand in 2000 to that in 2003?
Your answer should be very brief. 1.36. What is the ratio of the Expenditure(as % of GDP) of Albania in 2001 to that in 2002?
Offer a terse response. 1.09. What is the ratio of the Expenditure(as % of GDP) in Bolivia in 2001 to that in 2002?
Your answer should be very brief. 0.95. What is the ratio of the Expenditure(as % of GDP) of Thailand in 2001 to that in 2002?
Your answer should be compact. 1.23. What is the ratio of the Expenditure(as % of GDP) of Albania in 2001 to that in 2003?
Keep it short and to the point. 1.06. What is the ratio of the Expenditure(as % of GDP) in Bolivia in 2001 to that in 2003?
Offer a very short reply. 0.92. What is the ratio of the Expenditure(as % of GDP) in Jamaica in 2001 to that in 2003?
Keep it short and to the point. 1.27. What is the ratio of the Expenditure(as % of GDP) in Thailand in 2001 to that in 2003?
Provide a short and direct response. 1.26. What is the ratio of the Expenditure(as % of GDP) in Albania in 2002 to that in 2003?
Provide a succinct answer. 0.98. What is the ratio of the Expenditure(as % of GDP) in Bolivia in 2002 to that in 2003?
Provide a short and direct response. 0.98. What is the ratio of the Expenditure(as % of GDP) in Jamaica in 2002 to that in 2003?
Offer a terse response. 1.28. What is the ratio of the Expenditure(as % of GDP) in Thailand in 2002 to that in 2003?
Your response must be concise. 1.03. What is the difference between the highest and the second highest Expenditure(as % of GDP) of Albania?
Your answer should be compact. 0.45. What is the difference between the highest and the second highest Expenditure(as % of GDP) in Bolivia?
Make the answer very short. 0.15. What is the difference between the highest and the second highest Expenditure(as % of GDP) in Jamaica?
Your answer should be compact. 0.01. What is the difference between the highest and the second highest Expenditure(as % of GDP) of Thailand?
Offer a terse response. 0.39. What is the difference between the highest and the lowest Expenditure(as % of GDP) of Albania?
Offer a very short reply. 0.72. What is the difference between the highest and the lowest Expenditure(as % of GDP) of Bolivia?
Provide a succinct answer. 1.72. What is the difference between the highest and the lowest Expenditure(as % of GDP) in Jamaica?
Provide a short and direct response. 1.69. What is the difference between the highest and the lowest Expenditure(as % of GDP) in Thailand?
Make the answer very short. 2.24. 